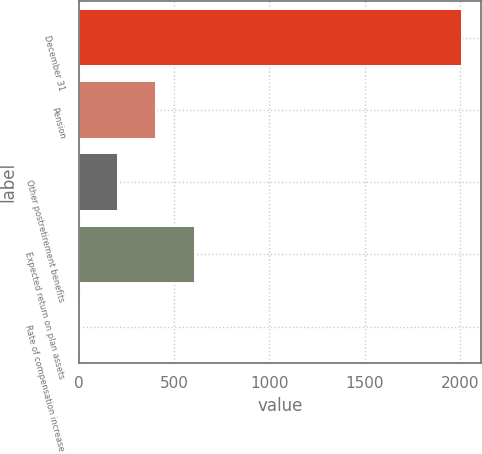Convert chart. <chart><loc_0><loc_0><loc_500><loc_500><bar_chart><fcel>December 31<fcel>Pension<fcel>Other postretirement benefits<fcel>Expected return on plan assets<fcel>Rate of compensation increase<nl><fcel>2013<fcel>405.8<fcel>204.9<fcel>606.7<fcel>4<nl></chart> 